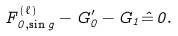Convert formula to latex. <formula><loc_0><loc_0><loc_500><loc_500>F ^ { ( \ell ) } _ { 0 , \sin g } - G ^ { \prime } _ { 0 } - G _ { 1 } \hat { = } \, 0 .</formula> 